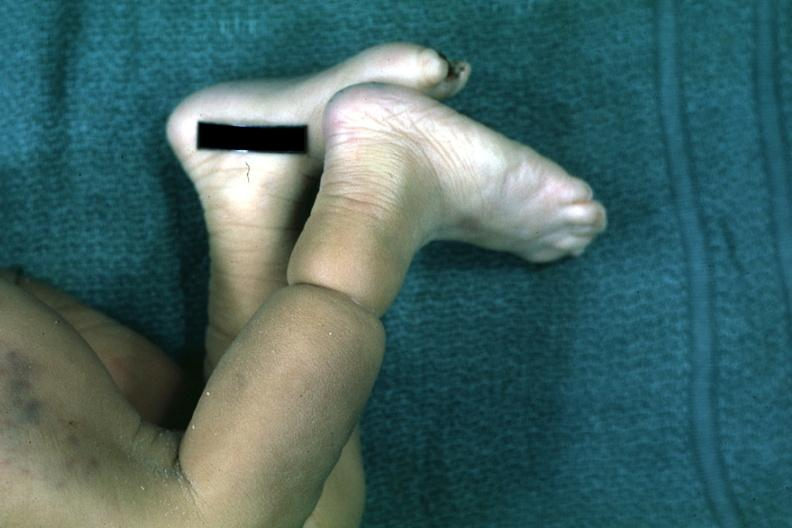re extremities present?
Answer the question using a single word or phrase. Yes 